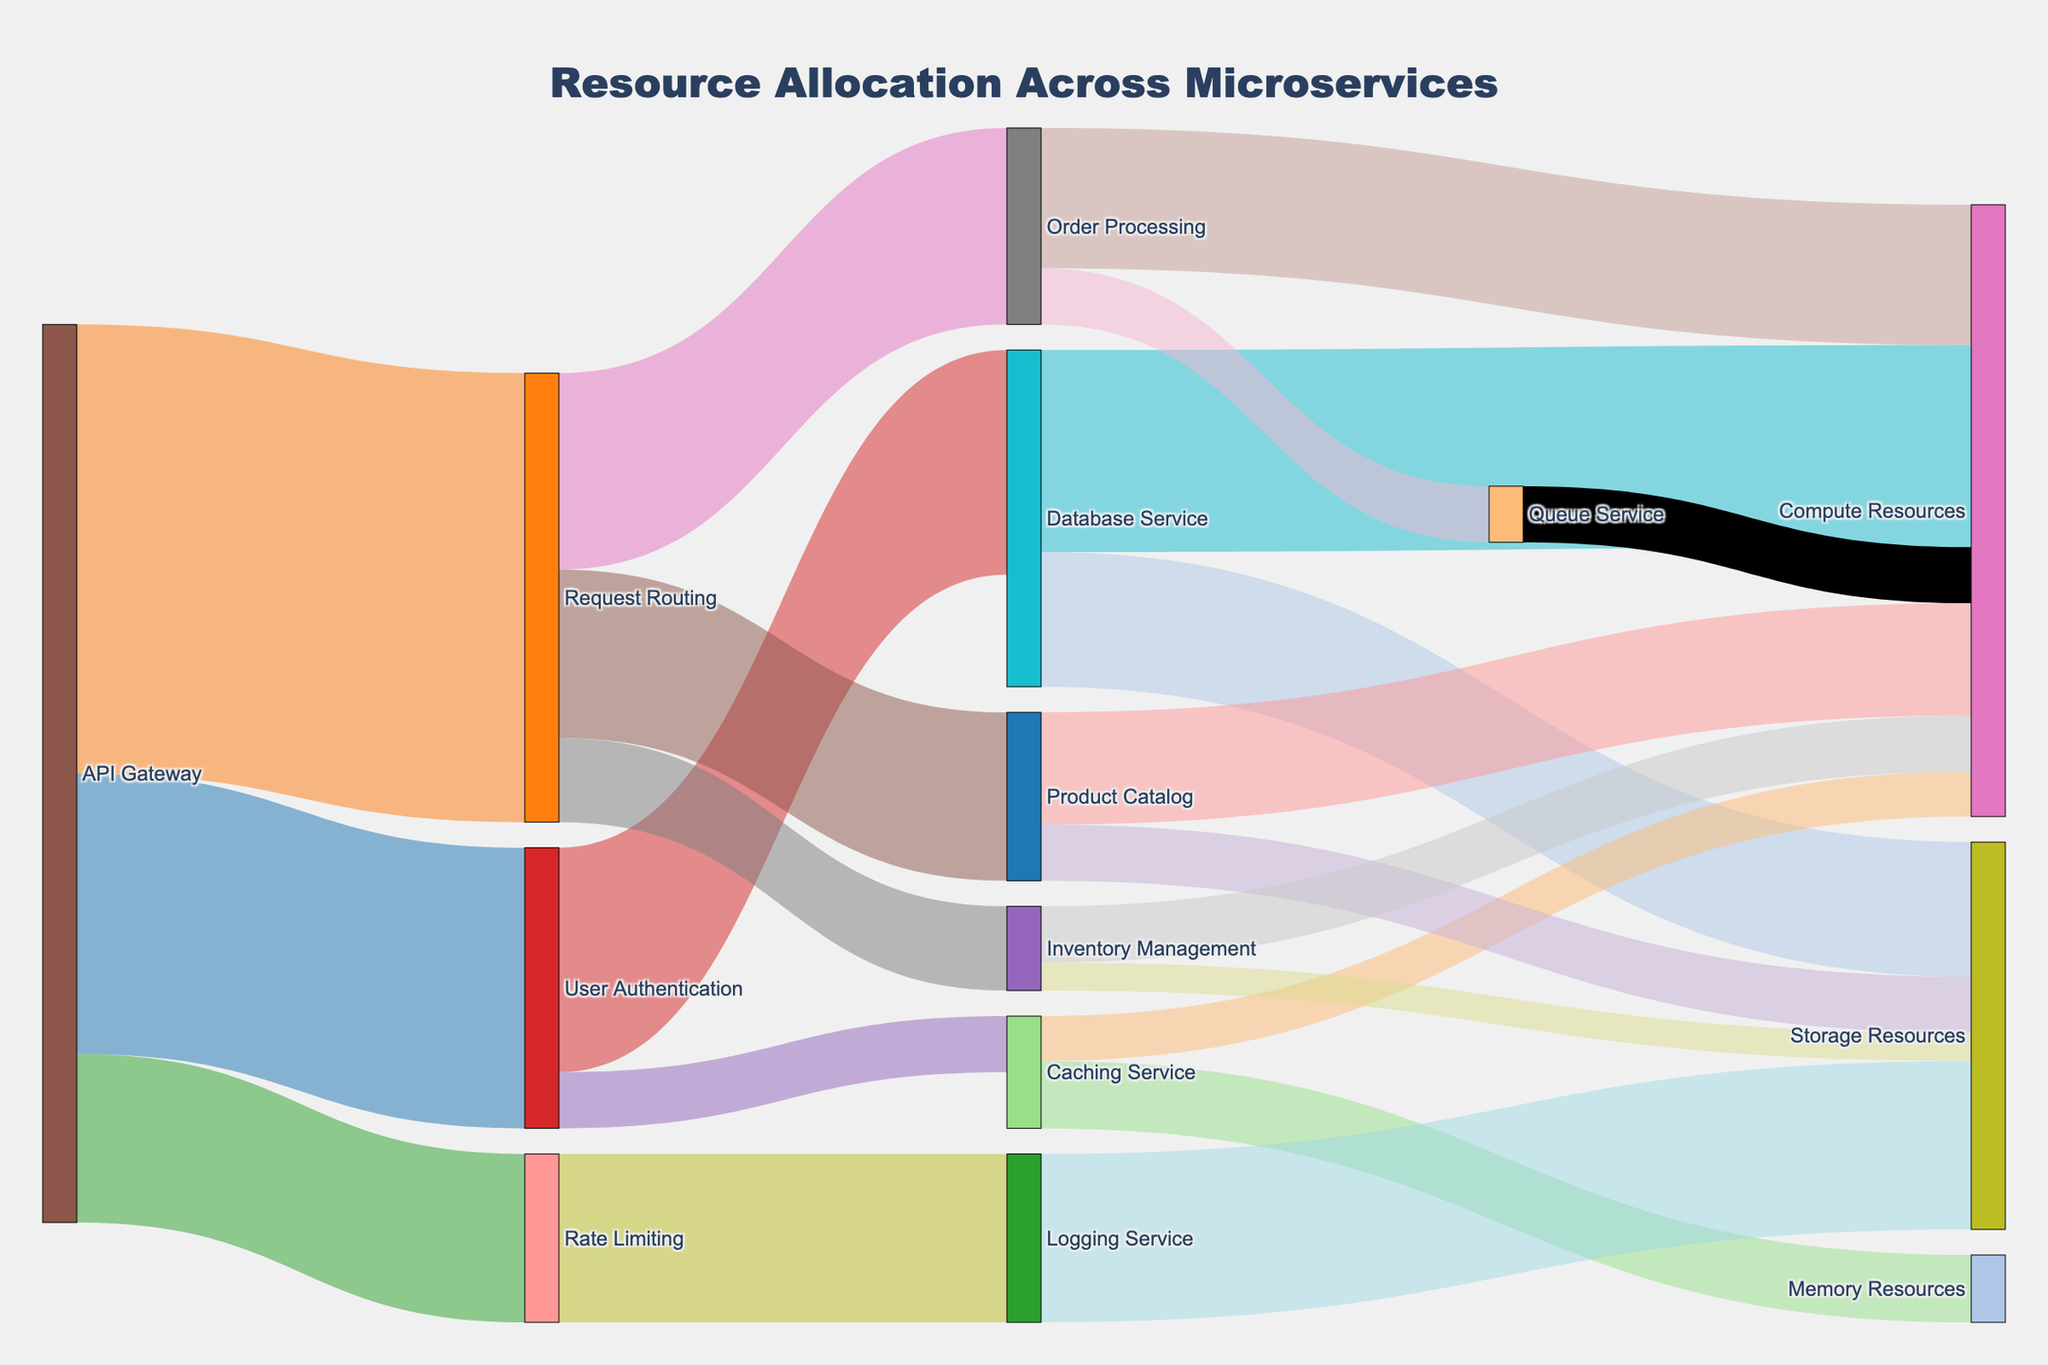What is the title of the Sankey diagram? The title is located at the top of the diagram. It helps describe the main subject of the figure.
Answer: "Resource Allocation Across Microservices" Which microservice receives the highest allocation from the API Gateway? Look at the arrows originating from "API Gateway" and compare the values. The largest value will indicate the highest allocation.
Answer: Request Routing How many paths lead out from the "User Authentication" microservice? Count the number of outgoing arrows from the "User Authentication" node.
Answer: Two What is the combined resource allocation for "Database Service"? Sum up the values of all incoming arrows to "Database Service". The values are 200 (from User Authentication) and 120 (from API Gateway).
Answer: 320 What percentage of the "Request Routing" resources is allocated to "Order Processing"? Determine the percentage by dividing the "Order Processing" value (175) by the total outgoing value from "Request Routing" (150 + 175 + 75 = 400), then multiply by 100.
Answer: 43.75% Which microservice has the smallest allocation from the API Gateway? Look at the values of arrows from "API Gateway" and find the smallest value.
Answer: Rate Limiting How does the allocation of "Compute Resources" from "Order Processing" compare to "Inventory Management"? Compare the values of the arrows from "Order Processing" (125) and "Inventory Management" (50) going to "Compute Resources".
Answer: Order Processing has a higher allocation What type of resource receives the highest allocation from "Database Service"? Look at the outgoing arrows from "Database Service" and identify which has the highest value.
Answer: Compute Resources What is the total resource allocation from the "Request Routing" microservice? Sum the values of all outgoing arrows from "Request Routing": 150 to Product Catalog, 175 to Order Processing, and 75 to Inventory Management.
Answer: 400 Which microservice directly interacts with the "Queue Service"? Look for any arrows connecting to or from the "Queue Service".
Answer: Order Processing 